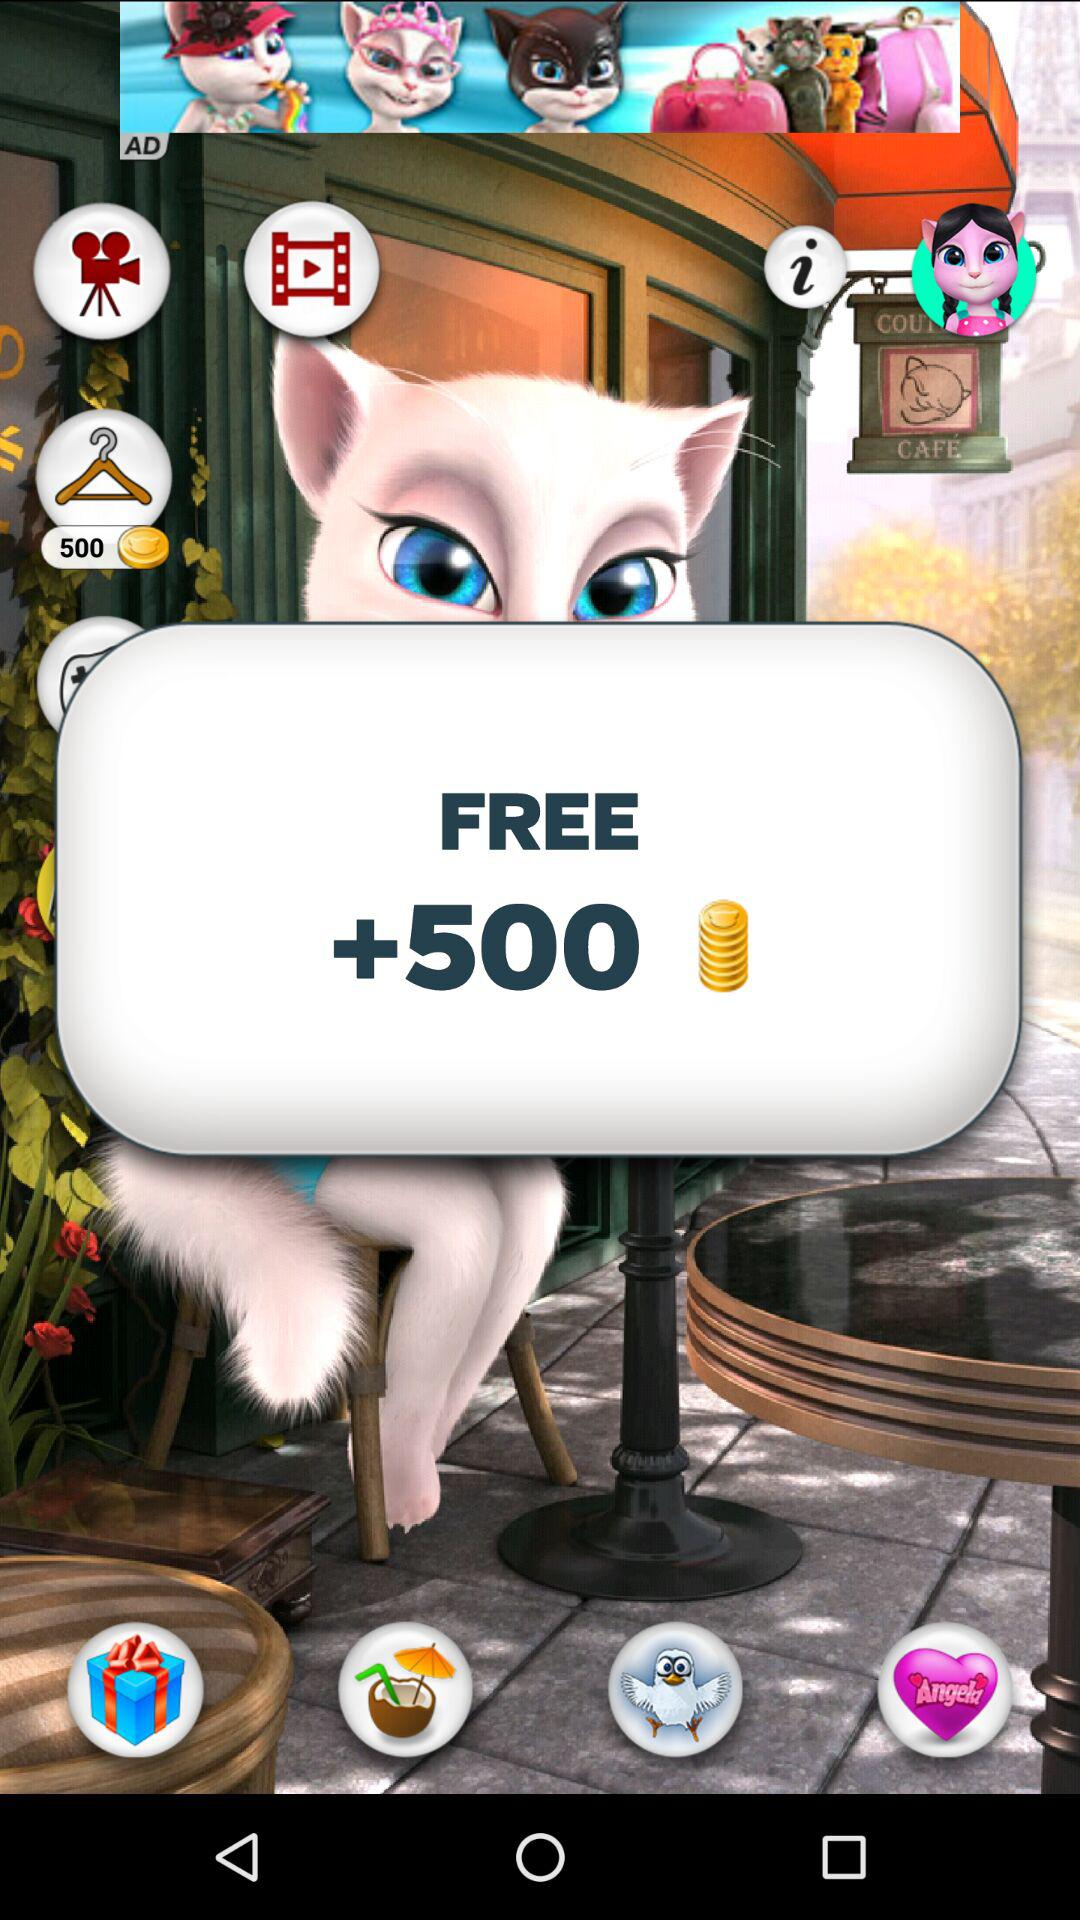How much more is the value of the coins than the cost of the hanger?
Answer the question using a single word or phrase. 500 